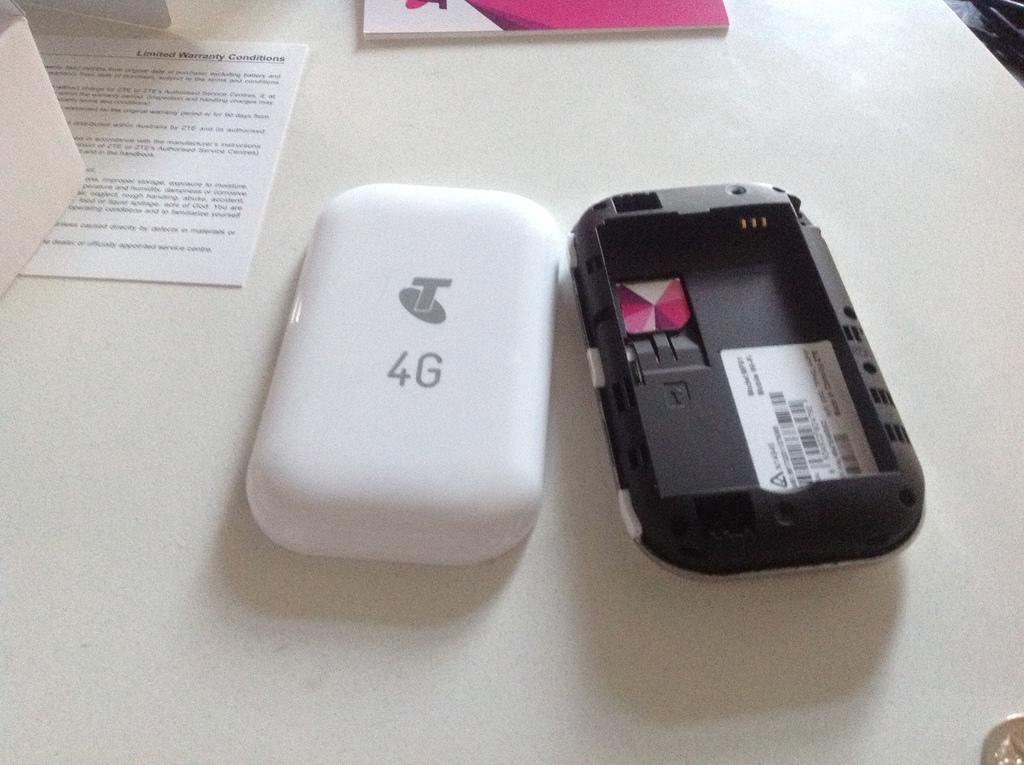<image>
Offer a succinct explanation of the picture presented. A white 4g phone with the back removed. 